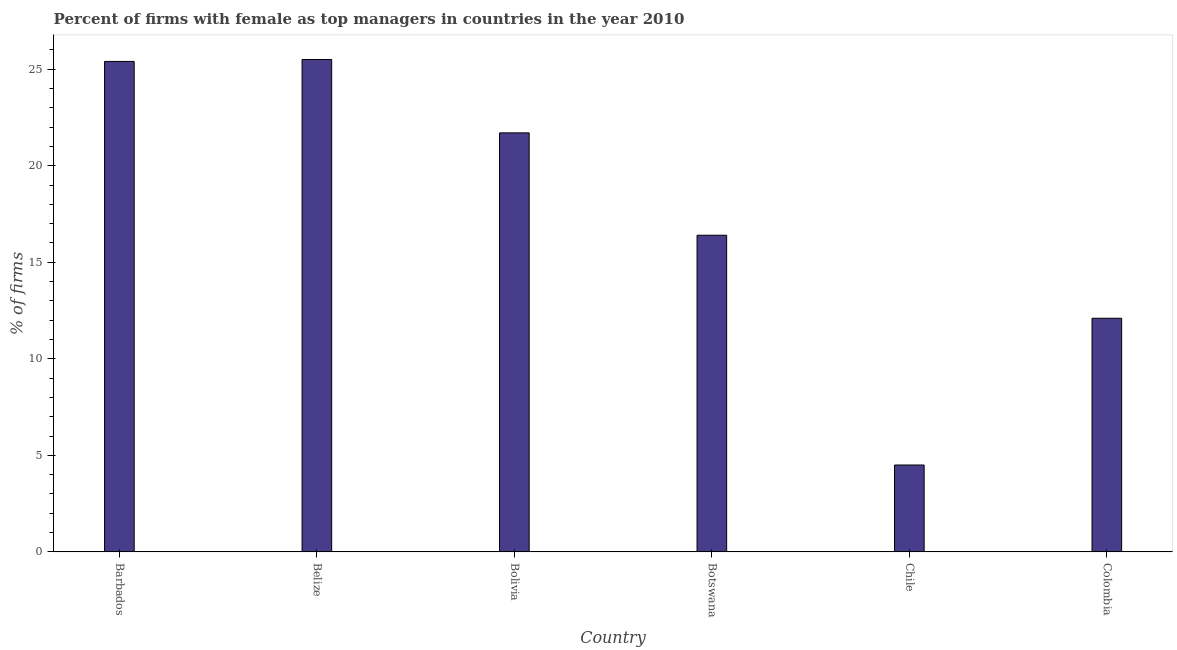Does the graph contain grids?
Your answer should be very brief. No. What is the title of the graph?
Offer a very short reply. Percent of firms with female as top managers in countries in the year 2010. What is the label or title of the X-axis?
Ensure brevity in your answer.  Country. What is the label or title of the Y-axis?
Give a very brief answer. % of firms. What is the percentage of firms with female as top manager in Botswana?
Offer a very short reply. 16.4. Across all countries, what is the maximum percentage of firms with female as top manager?
Your answer should be compact. 25.5. In which country was the percentage of firms with female as top manager maximum?
Give a very brief answer. Belize. What is the sum of the percentage of firms with female as top manager?
Your answer should be compact. 105.6. What is the difference between the percentage of firms with female as top manager in Barbados and Botswana?
Make the answer very short. 9. What is the median percentage of firms with female as top manager?
Keep it short and to the point. 19.05. In how many countries, is the percentage of firms with female as top manager greater than 25 %?
Ensure brevity in your answer.  2. Is the percentage of firms with female as top manager in Belize less than that in Colombia?
Make the answer very short. No. Are all the bars in the graph horizontal?
Provide a succinct answer. No. What is the % of firms of Barbados?
Provide a short and direct response. 25.4. What is the % of firms in Belize?
Make the answer very short. 25.5. What is the % of firms in Bolivia?
Your answer should be compact. 21.7. What is the % of firms in Botswana?
Your response must be concise. 16.4. What is the difference between the % of firms in Barbados and Chile?
Ensure brevity in your answer.  20.9. What is the difference between the % of firms in Belize and Bolivia?
Give a very brief answer. 3.8. What is the difference between the % of firms in Belize and Chile?
Provide a succinct answer. 21. What is the difference between the % of firms in Belize and Colombia?
Your answer should be very brief. 13.4. What is the difference between the % of firms in Bolivia and Chile?
Offer a terse response. 17.2. What is the difference between the % of firms in Botswana and Colombia?
Offer a terse response. 4.3. What is the ratio of the % of firms in Barbados to that in Belize?
Your answer should be compact. 1. What is the ratio of the % of firms in Barbados to that in Bolivia?
Give a very brief answer. 1.17. What is the ratio of the % of firms in Barbados to that in Botswana?
Offer a very short reply. 1.55. What is the ratio of the % of firms in Barbados to that in Chile?
Your response must be concise. 5.64. What is the ratio of the % of firms in Barbados to that in Colombia?
Keep it short and to the point. 2.1. What is the ratio of the % of firms in Belize to that in Bolivia?
Your answer should be compact. 1.18. What is the ratio of the % of firms in Belize to that in Botswana?
Make the answer very short. 1.55. What is the ratio of the % of firms in Belize to that in Chile?
Keep it short and to the point. 5.67. What is the ratio of the % of firms in Belize to that in Colombia?
Provide a succinct answer. 2.11. What is the ratio of the % of firms in Bolivia to that in Botswana?
Provide a short and direct response. 1.32. What is the ratio of the % of firms in Bolivia to that in Chile?
Offer a very short reply. 4.82. What is the ratio of the % of firms in Bolivia to that in Colombia?
Provide a short and direct response. 1.79. What is the ratio of the % of firms in Botswana to that in Chile?
Provide a succinct answer. 3.64. What is the ratio of the % of firms in Botswana to that in Colombia?
Give a very brief answer. 1.35. What is the ratio of the % of firms in Chile to that in Colombia?
Provide a succinct answer. 0.37. 